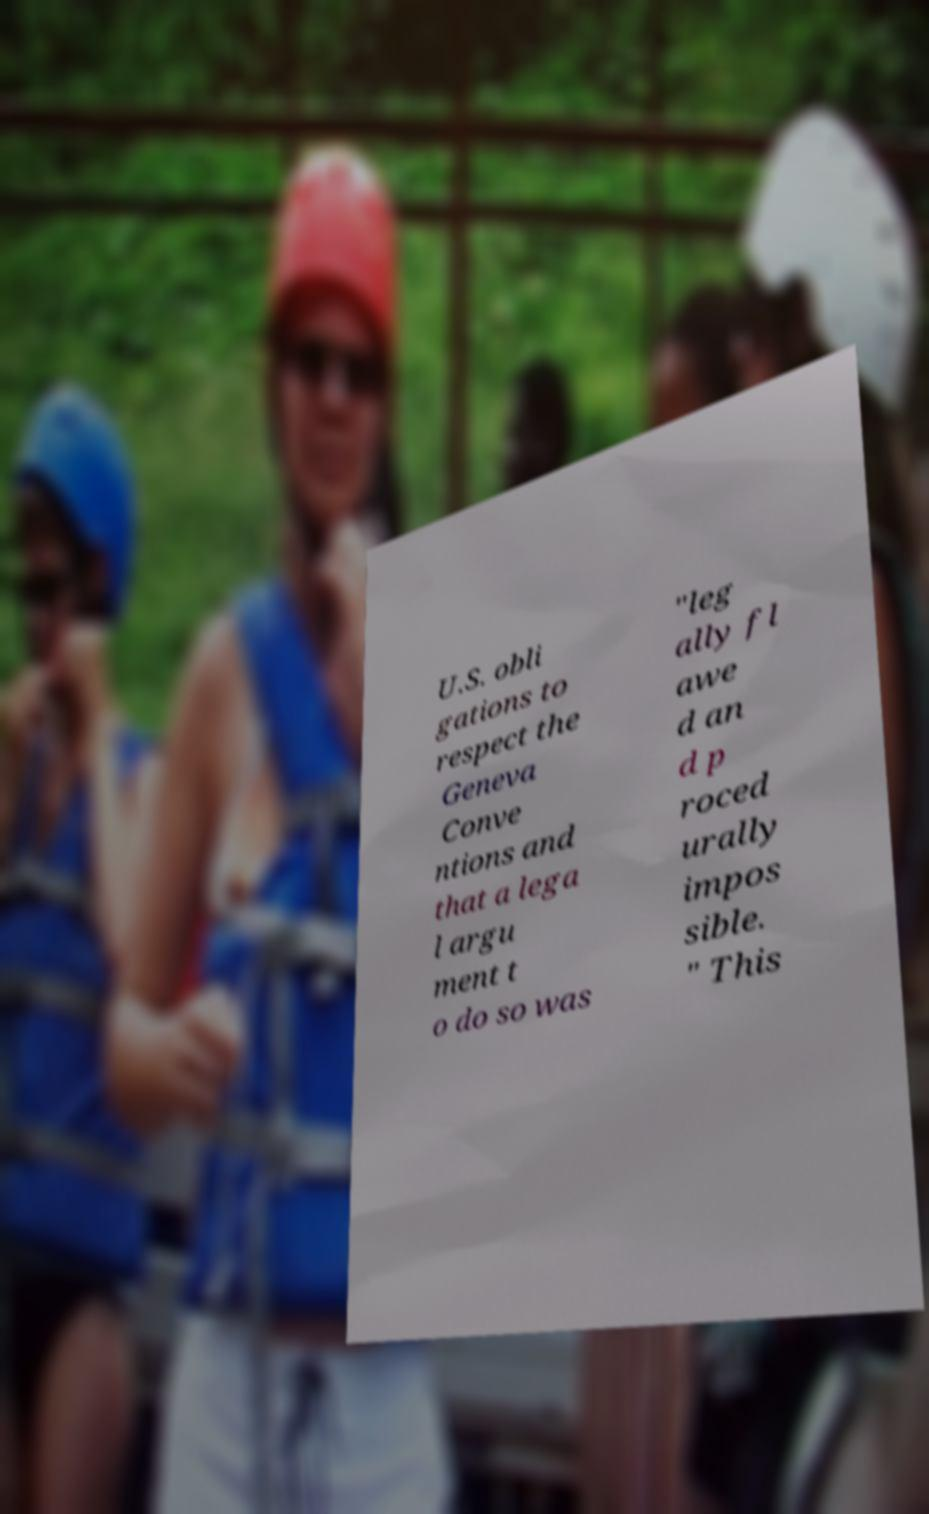Please read and relay the text visible in this image. What does it say? U.S. obli gations to respect the Geneva Conve ntions and that a lega l argu ment t o do so was "leg ally fl awe d an d p roced urally impos sible. " This 